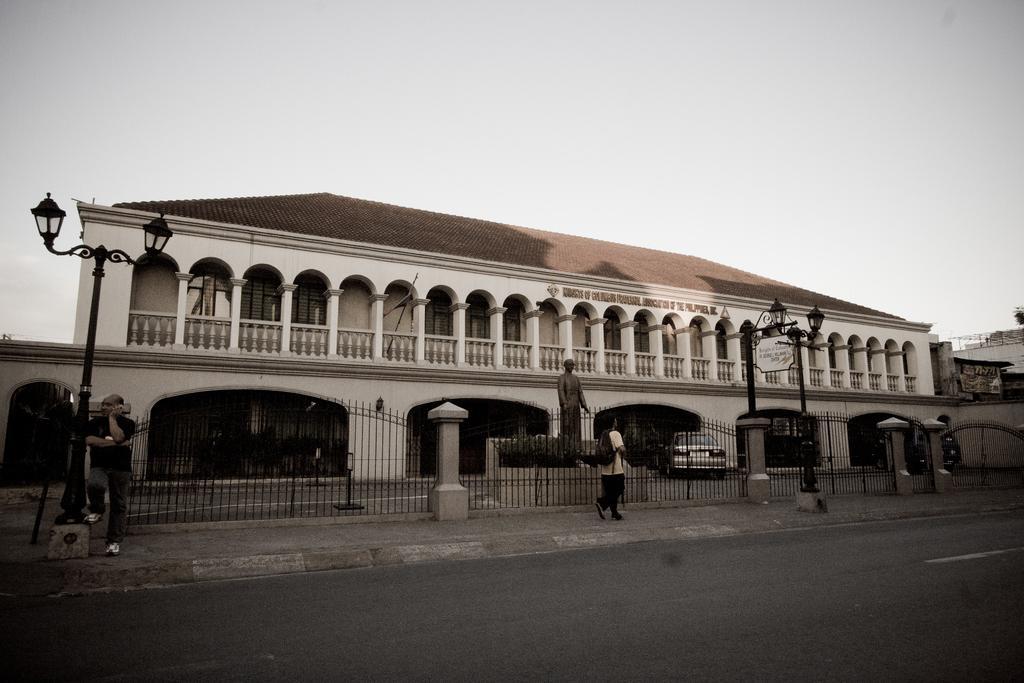Could you give a brief overview of what you see in this image? This is a building, this is car, here a person is standing another is walking, this is road and a sky. 